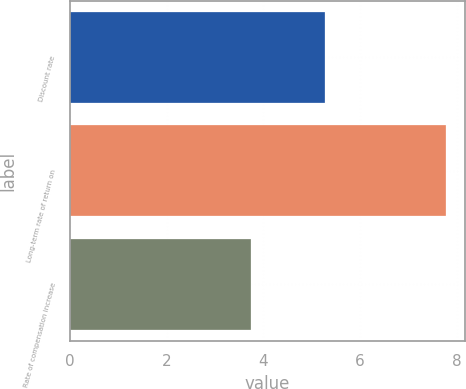<chart> <loc_0><loc_0><loc_500><loc_500><bar_chart><fcel>Discount rate<fcel>Long-term rate of return on<fcel>Rate of compensation increase<nl><fcel>5.27<fcel>7.77<fcel>3.75<nl></chart> 